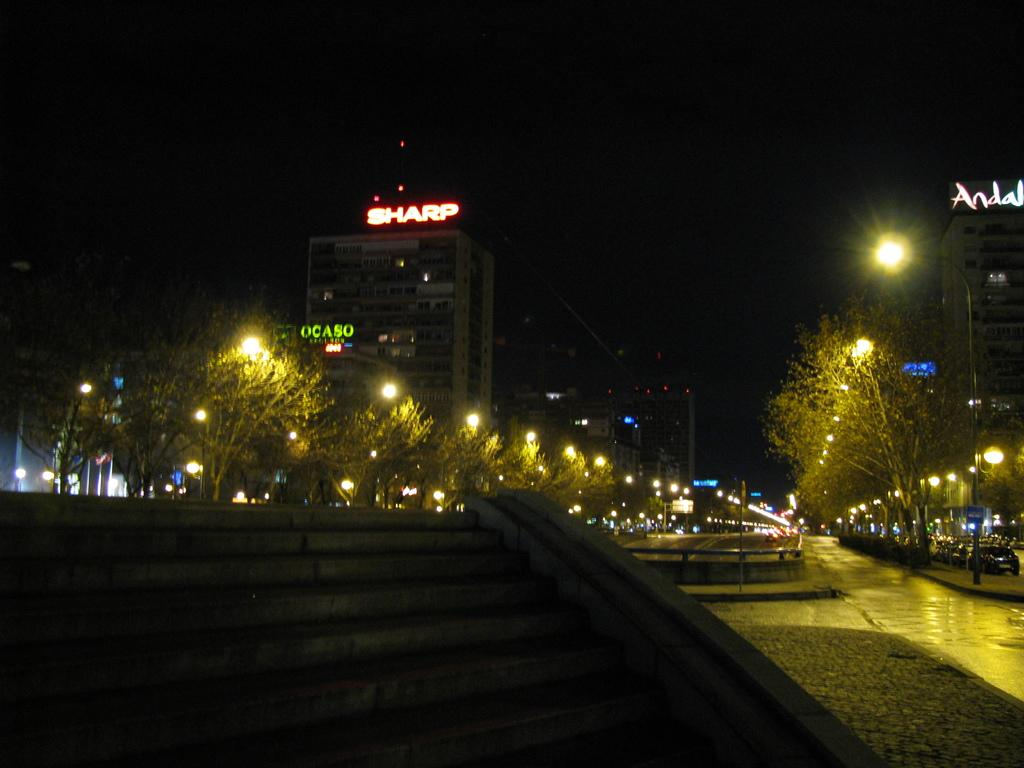What type of architectural feature can be seen in the image? There are steps in the image. What type of transportation infrastructure is present in the image? There is a road in the image. What type of lighting is present in the image? There are light poles in the image. What type of vehicles can be seen in the image? There are vehicles in the image. What type of natural elements are present in the image? There are trees in the image. What type of man-made structures are present in the image? There are buildings in the image. What type of signage is present on the buildings in the image? There are name boards on the buildings in the image. What is the color of the background in the image? The background of the image is dark. What word is written on the stomach of the person in the image? There is no person present in the image, and therefore no stomach or word written on it. 